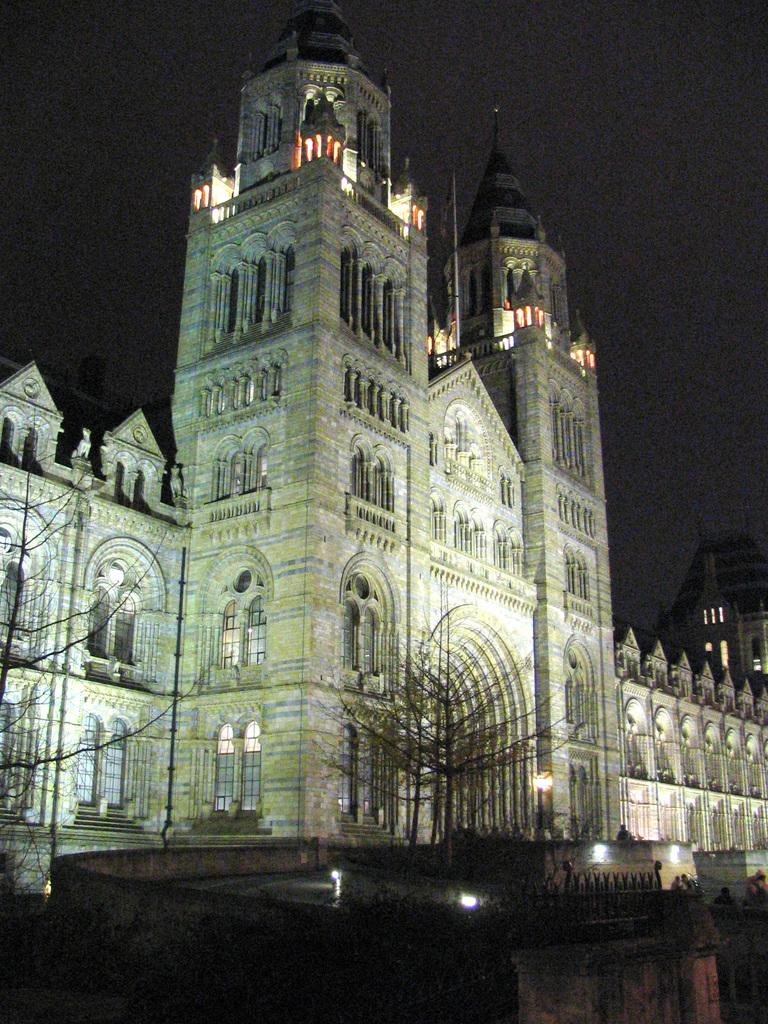At what time of day was the image taken? The image was taken during night time. What type of structure can be seen in the image? There is a building in the image. What other natural elements are present in the image? There are trees in the image. What can be seen illuminating the scene in the image? Lights are visible in the image. Are there any living beings present in the image? Yes, there are people visible in the image. What part of the natural environment is visible in the image? The sky is present in the image. What type of can is visible in the image? There is no can present in the image. What message of peace can be seen in the image? There is no message of peace depicted in the image. 